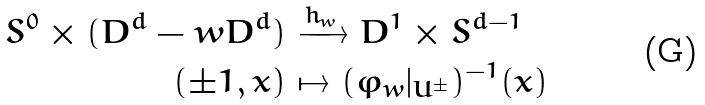Convert formula to latex. <formula><loc_0><loc_0><loc_500><loc_500>S ^ { 0 } \times ( D ^ { d } - w D ^ { d } ) & \xrightarrow { h _ { w } } D ^ { 1 } \times S ^ { d - 1 } \\ ( \pm 1 , x ) & \mapsto ( \varphi _ { w } | _ { U ^ { \pm } } ) ^ { - 1 } ( x )</formula> 